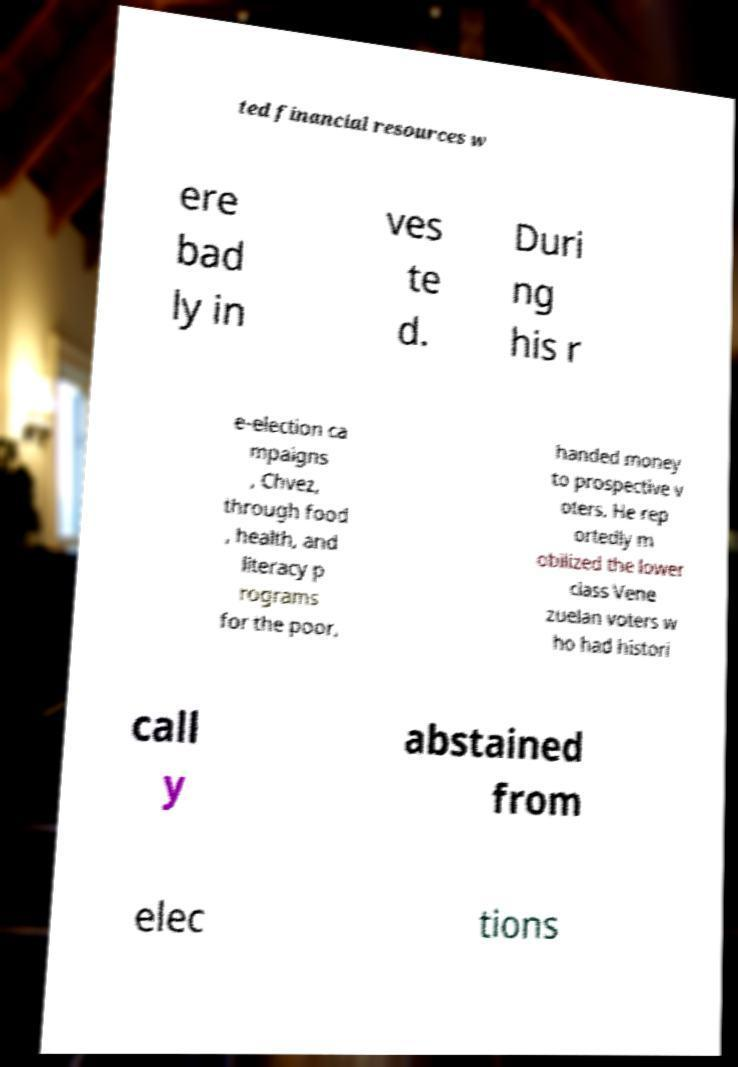What messages or text are displayed in this image? I need them in a readable, typed format. ted financial resources w ere bad ly in ves te d. Duri ng his r e-election ca mpaigns , Chvez, through food , health, and literacy p rograms for the poor, handed money to prospective v oters. He rep ortedly m obilized the lower class Vene zuelan voters w ho had histori call y abstained from elec tions 